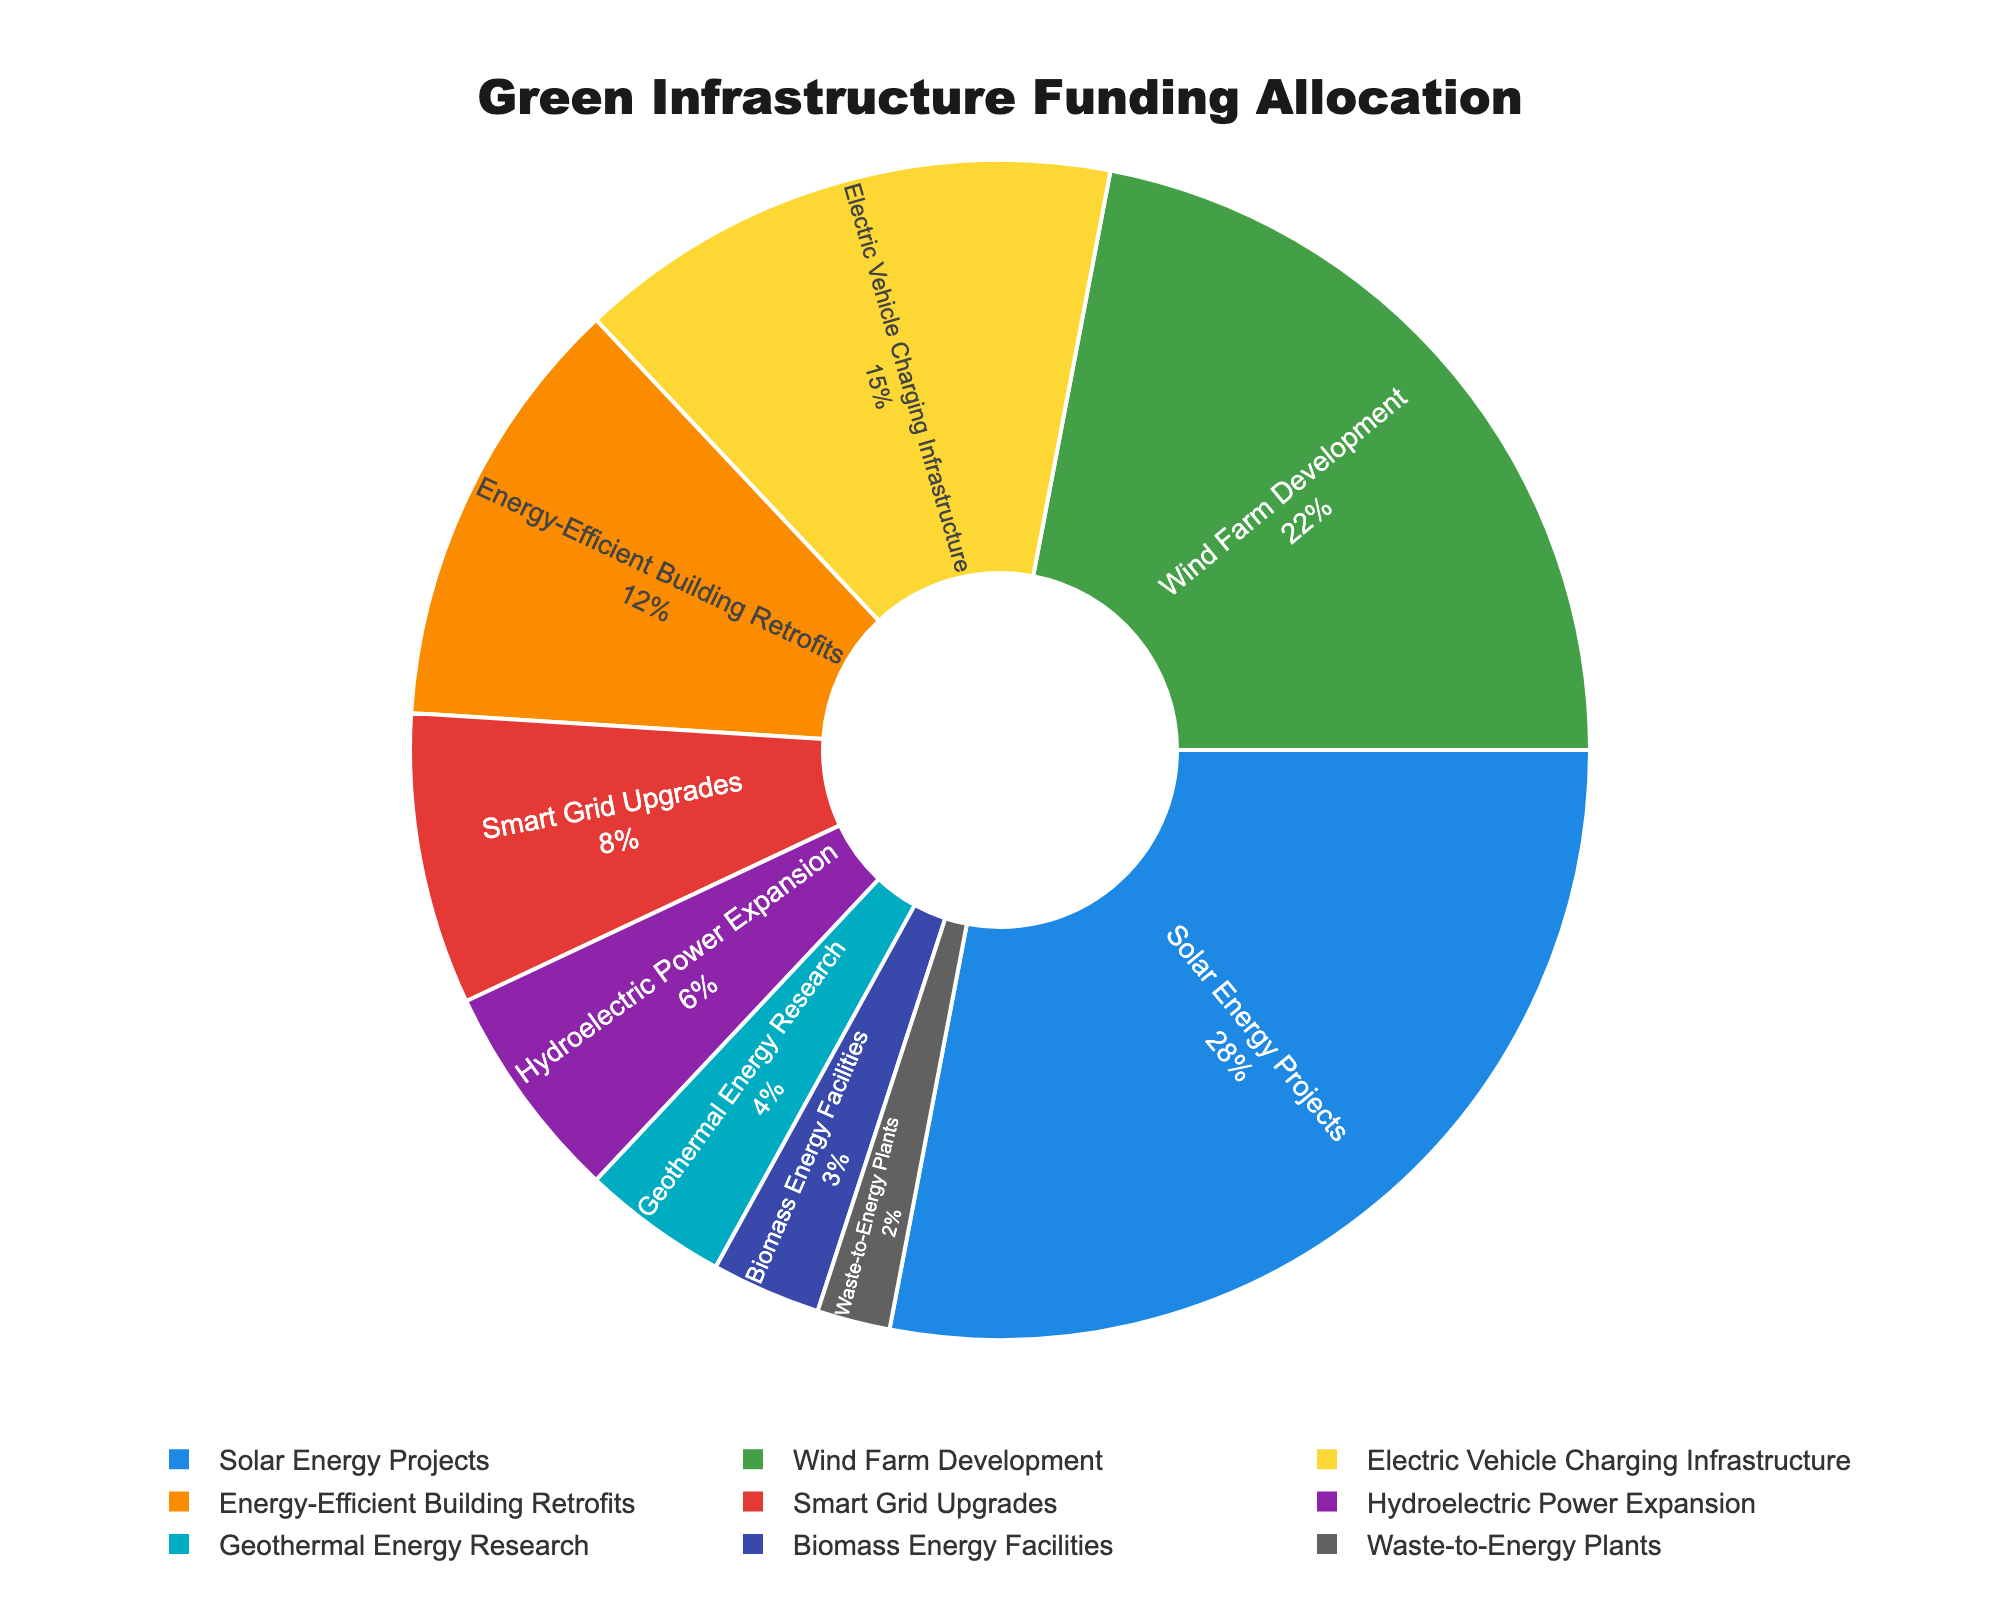Which sector received the highest percentage of funding? By looking at the pie chart, identify the segment with the largest portion. The label provides a percentage for each sector. The segment labeled "Solar Energy Projects" has the highest percentage, 28%.
Answer: Solar Energy Projects Which two sectors together received 40% of the funding? Add the percentages of each sector together until you find a total of 40%. Solar Energy Projects (28%) plus Electric Vehicle Charging Infrastructure (12%) equals 40%.
Answer: Solar Energy Projects and Energy-Efficient Building Retrofits What is the difference in funding allocation between Wind Farm Development and Hydroelectric Power Expansion? Find the percentage for Wind Farm Development (22%) and Hydroelectric Power Expansion (6%) and subtract the smaller from the larger. 22% - 6% = 16%.
Answer: 16% Which sector received more funding: Smart Grid Upgrades or Geothermal Energy Research? Compare the values of Smart Grid Upgrades (8%) and Geothermal Energy Research (4%). Smart Grid Upgrades has a greater percentage.
Answer: Smart Grid Upgrades What is the combined funding allocation for solar and wind energy projects? Add the percentage of funding for Solar Energy Projects (28%) and Wind Farm Development (22%) to get 28% + 22% = 50%.
Answer: 50% Which sector has the smallest allocation, and what percentage is it? Look for the segment with the smallest portion and read its label. Waste-to-Energy Plants, at 2%, has the smallest allocation.
Answer: Waste-to-Energy Plants, 2% If we were to group Solar Energy, Wind Farm Development, and Electric Vehicle Charging Infrastructure together, what percentage of the total funding would this group receive? Add the percentages of these sectors: Solar Energy Projects (28%) + Wind Farm Development (22%) + Electric Vehicle Charging Infrastructure (15%) equals 65%.
Answer: 65% Are there any sectors with equal funding allocation percentages? Review all the sectors and compare their percentages. None of the sectors have the same percentage.
Answer: No What is the second-largest funding allocation, and which sector does it belong to? Identify the second largest segment after the largest one. Wind Farm Development has the second-largest allocation with 22%.
Answer: Wind Farm Development, 22% How does the funding for Electric Vehicle Charging Infrastructure compare to that for Smart Grid Upgrades? Compare the percentages: Electric Vehicle Charging Infrastructure (15%) is greater than Smart Grid Upgrades (8%).
Answer: Electric Vehicle Charging Infrastructure is greater 